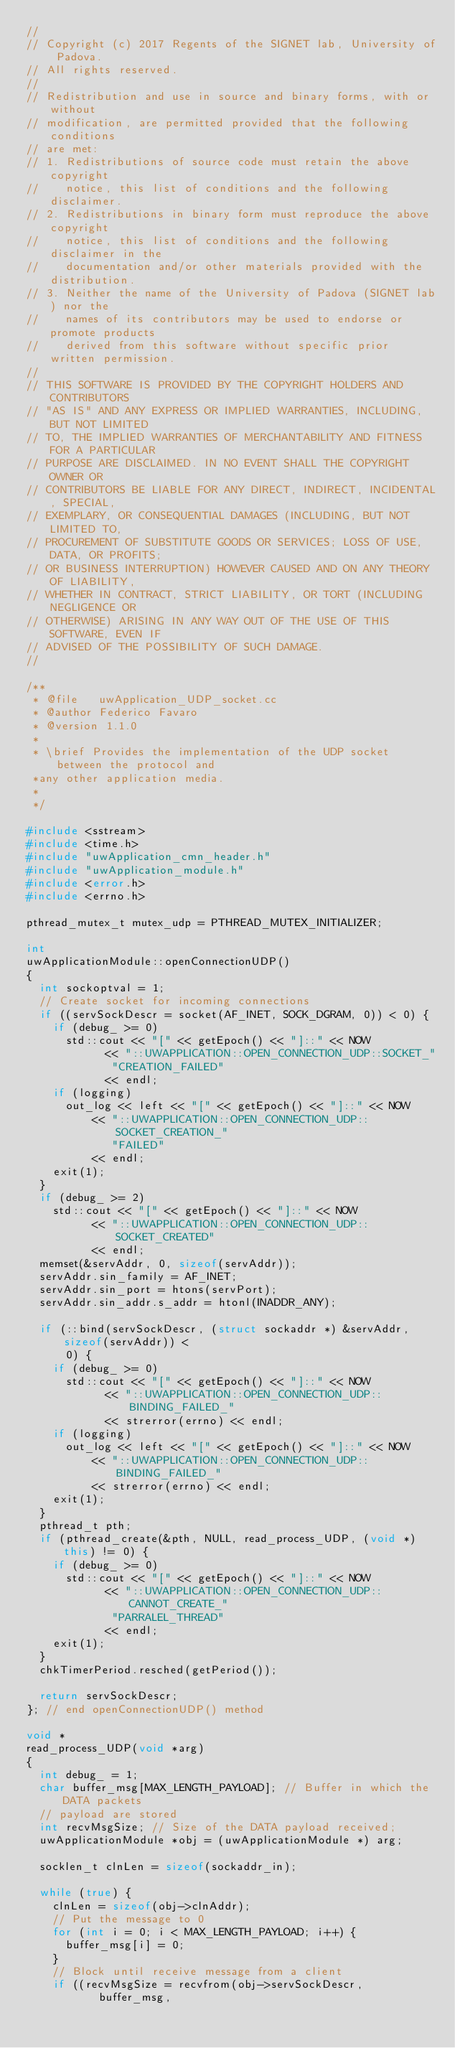<code> <loc_0><loc_0><loc_500><loc_500><_C++_>//
// Copyright (c) 2017 Regents of the SIGNET lab, University of Padova.
// All rights reserved.
//
// Redistribution and use in source and binary forms, with or without
// modification, are permitted provided that the following conditions
// are met:
// 1. Redistributions of source code must retain the above copyright
//    notice, this list of conditions and the following disclaimer.
// 2. Redistributions in binary form must reproduce the above copyright
//    notice, this list of conditions and the following disclaimer in the
//    documentation and/or other materials provided with the distribution.
// 3. Neither the name of the University of Padova (SIGNET lab) nor the
//    names of its contributors may be used to endorse or promote products
//    derived from this software without specific prior written permission.
//
// THIS SOFTWARE IS PROVIDED BY THE COPYRIGHT HOLDERS AND CONTRIBUTORS
// "AS IS" AND ANY EXPRESS OR IMPLIED WARRANTIES, INCLUDING, BUT NOT LIMITED
// TO, THE IMPLIED WARRANTIES OF MERCHANTABILITY AND FITNESS FOR A PARTICULAR
// PURPOSE ARE DISCLAIMED. IN NO EVENT SHALL THE COPYRIGHT OWNER OR
// CONTRIBUTORS BE LIABLE FOR ANY DIRECT, INDIRECT, INCIDENTAL, SPECIAL,
// EXEMPLARY, OR CONSEQUENTIAL DAMAGES (INCLUDING, BUT NOT LIMITED TO,
// PROCUREMENT OF SUBSTITUTE GOODS OR SERVICES; LOSS OF USE, DATA, OR PROFITS;
// OR BUSINESS INTERRUPTION) HOWEVER CAUSED AND ON ANY THEORY OF LIABILITY,
// WHETHER IN CONTRACT, STRICT LIABILITY, OR TORT (INCLUDING NEGLIGENCE OR
// OTHERWISE) ARISING IN ANY WAY OUT OF THE USE OF THIS SOFTWARE, EVEN IF
// ADVISED OF THE POSSIBILITY OF SUCH DAMAGE.
//

/**
 * @file   uwApplication_UDP_socket.cc
 * @author Federico Favaro
 * @version 1.1.0
 *
 * \brief Provides the implementation of the UDP socket between the protocol and
 *any other application media.
 *
 */

#include <sstream>
#include <time.h>
#include "uwApplication_cmn_header.h"
#include "uwApplication_module.h"
#include <error.h>
#include <errno.h>

pthread_mutex_t mutex_udp = PTHREAD_MUTEX_INITIALIZER;

int
uwApplicationModule::openConnectionUDP()
{
	int sockoptval = 1;
	// Create socket for incoming connections
	if ((servSockDescr = socket(AF_INET, SOCK_DGRAM, 0)) < 0) {
		if (debug_ >= 0)
			std::cout << "[" << getEpoch() << "]::" << NOW
					  << "::UWAPPLICATION::OPEN_CONNECTION_UDP::SOCKET_"
						 "CREATION_FAILED"
					  << endl;
		if (logging)
			out_log << left << "[" << getEpoch() << "]::" << NOW
					<< "::UWAPPLICATION::OPEN_CONNECTION_UDP::SOCKET_CREATION_"
					   "FAILED"
					<< endl;
		exit(1);
	}
	if (debug_ >= 2)
		std::cout << "[" << getEpoch() << "]::" << NOW
				  << "::UWAPPLICATION::OPEN_CONNECTION_UDP::SOCKET_CREATED"
				  << endl;
	memset(&servAddr, 0, sizeof(servAddr));
	servAddr.sin_family = AF_INET;
	servAddr.sin_port = htons(servPort);
	servAddr.sin_addr.s_addr = htonl(INADDR_ANY);

	if (::bind(servSockDescr, (struct sockaddr *) &servAddr, sizeof(servAddr)) <
			0) {
		if (debug_ >= 0)
			std::cout << "[" << getEpoch() << "]::" << NOW
					  << "::UWAPPLICATION::OPEN_CONNECTION_UDP::BINDING_FAILED_"
					  << strerror(errno) << endl;
		if (logging)
			out_log << left << "[" << getEpoch() << "]::" << NOW
					<< "::UWAPPLICATION::OPEN_CONNECTION_UDP::BINDING_FAILED_"
					<< strerror(errno) << endl;
		exit(1);
	}
	pthread_t pth;
	if (pthread_create(&pth, NULL, read_process_UDP, (void *) this) != 0) {
		if (debug_ >= 0)
			std::cout << "[" << getEpoch() << "]::" << NOW
					  << "::UWAPPLICATION::OPEN_CONNECTION_UDP::CANNOT_CREATE_"
						 "PARRALEL_THREAD"
					  << endl;
		exit(1);
	}
	chkTimerPeriod.resched(getPeriod());

	return servSockDescr;
}; // end openConnectionUDP() method

void *
read_process_UDP(void *arg)
{
	int debug_ = 1;
	char buffer_msg[MAX_LENGTH_PAYLOAD]; // Buffer in which the DATA packets
	// payload are stored
	int recvMsgSize; // Size of the DATA payload received;
	uwApplicationModule *obj = (uwApplicationModule *) arg;

	socklen_t clnLen = sizeof(sockaddr_in);

	while (true) {
		clnLen = sizeof(obj->clnAddr);
		// Put the message to 0
		for (int i = 0; i < MAX_LENGTH_PAYLOAD; i++) {
			buffer_msg[i] = 0;
		}
		// Block until receive message from a client
		if ((recvMsgSize = recvfrom(obj->servSockDescr,
					 buffer_msg,</code> 